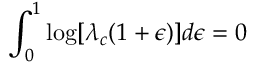<formula> <loc_0><loc_0><loc_500><loc_500>\int _ { 0 } ^ { 1 } \log [ \lambda _ { c } ( 1 + \epsilon ) ] d \epsilon = 0</formula> 